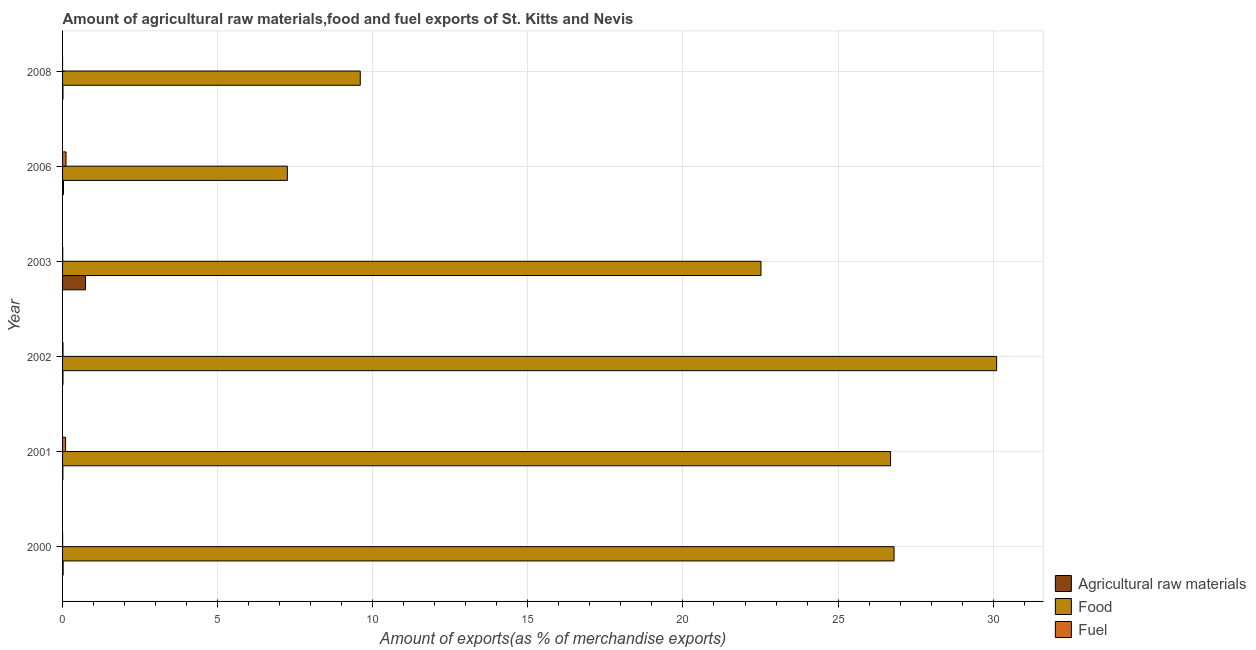How many different coloured bars are there?
Your answer should be very brief. 3. How many groups of bars are there?
Keep it short and to the point. 6. Are the number of bars per tick equal to the number of legend labels?
Keep it short and to the point. Yes. Are the number of bars on each tick of the Y-axis equal?
Ensure brevity in your answer.  Yes. What is the label of the 1st group of bars from the top?
Provide a succinct answer. 2008. In how many cases, is the number of bars for a given year not equal to the number of legend labels?
Provide a short and direct response. 0. What is the percentage of raw materials exports in 2003?
Your answer should be very brief. 0.74. Across all years, what is the maximum percentage of food exports?
Make the answer very short. 30.11. Across all years, what is the minimum percentage of food exports?
Your answer should be compact. 7.25. In which year was the percentage of food exports minimum?
Offer a terse response. 2006. What is the total percentage of raw materials exports in the graph?
Your answer should be compact. 0.82. What is the difference between the percentage of fuel exports in 2002 and that in 2006?
Offer a terse response. -0.1. What is the difference between the percentage of fuel exports in 2006 and the percentage of raw materials exports in 2008?
Provide a succinct answer. 0.1. What is the average percentage of food exports per year?
Make the answer very short. 20.49. In the year 2006, what is the difference between the percentage of food exports and percentage of fuel exports?
Your answer should be compact. 7.14. What is the ratio of the percentage of raw materials exports in 2003 to that in 2006?
Make the answer very short. 24.98. Is the difference between the percentage of fuel exports in 2002 and 2008 greater than the difference between the percentage of food exports in 2002 and 2008?
Your response must be concise. No. What is the difference between the highest and the second highest percentage of raw materials exports?
Ensure brevity in your answer.  0.71. What is the difference between the highest and the lowest percentage of raw materials exports?
Give a very brief answer. 0.73. In how many years, is the percentage of raw materials exports greater than the average percentage of raw materials exports taken over all years?
Ensure brevity in your answer.  1. Is the sum of the percentage of fuel exports in 2000 and 2008 greater than the maximum percentage of food exports across all years?
Your answer should be compact. No. What does the 3rd bar from the top in 2003 represents?
Keep it short and to the point. Agricultural raw materials. What does the 1st bar from the bottom in 2000 represents?
Your answer should be very brief. Agricultural raw materials. Is it the case that in every year, the sum of the percentage of raw materials exports and percentage of food exports is greater than the percentage of fuel exports?
Provide a short and direct response. Yes. How many years are there in the graph?
Keep it short and to the point. 6. Are the values on the major ticks of X-axis written in scientific E-notation?
Ensure brevity in your answer.  No. How are the legend labels stacked?
Offer a very short reply. Vertical. What is the title of the graph?
Keep it short and to the point. Amount of agricultural raw materials,food and fuel exports of St. Kitts and Nevis. Does "Ages 50+" appear as one of the legend labels in the graph?
Your answer should be compact. No. What is the label or title of the X-axis?
Your response must be concise. Amount of exports(as % of merchandise exports). What is the Amount of exports(as % of merchandise exports) in Agricultural raw materials in 2000?
Make the answer very short. 0.02. What is the Amount of exports(as % of merchandise exports) of Food in 2000?
Provide a succinct answer. 26.8. What is the Amount of exports(as % of merchandise exports) in Fuel in 2000?
Your answer should be very brief. 0. What is the Amount of exports(as % of merchandise exports) in Agricultural raw materials in 2001?
Your answer should be compact. 0.01. What is the Amount of exports(as % of merchandise exports) of Food in 2001?
Your response must be concise. 26.69. What is the Amount of exports(as % of merchandise exports) of Fuel in 2001?
Offer a terse response. 0.1. What is the Amount of exports(as % of merchandise exports) of Agricultural raw materials in 2002?
Your response must be concise. 0.01. What is the Amount of exports(as % of merchandise exports) of Food in 2002?
Your answer should be compact. 30.11. What is the Amount of exports(as % of merchandise exports) in Fuel in 2002?
Provide a succinct answer. 0.01. What is the Amount of exports(as % of merchandise exports) of Agricultural raw materials in 2003?
Provide a short and direct response. 0.74. What is the Amount of exports(as % of merchandise exports) of Food in 2003?
Your answer should be compact. 22.51. What is the Amount of exports(as % of merchandise exports) in Fuel in 2003?
Keep it short and to the point. 0.01. What is the Amount of exports(as % of merchandise exports) of Agricultural raw materials in 2006?
Provide a succinct answer. 0.03. What is the Amount of exports(as % of merchandise exports) of Food in 2006?
Keep it short and to the point. 7.25. What is the Amount of exports(as % of merchandise exports) in Fuel in 2006?
Your answer should be very brief. 0.11. What is the Amount of exports(as % of merchandise exports) in Agricultural raw materials in 2008?
Offer a very short reply. 0.01. What is the Amount of exports(as % of merchandise exports) of Food in 2008?
Your answer should be very brief. 9.6. What is the Amount of exports(as % of merchandise exports) in Fuel in 2008?
Your answer should be very brief. 6.97416001647576e-6. Across all years, what is the maximum Amount of exports(as % of merchandise exports) of Agricultural raw materials?
Make the answer very short. 0.74. Across all years, what is the maximum Amount of exports(as % of merchandise exports) in Food?
Provide a succinct answer. 30.11. Across all years, what is the maximum Amount of exports(as % of merchandise exports) in Fuel?
Give a very brief answer. 0.11. Across all years, what is the minimum Amount of exports(as % of merchandise exports) of Agricultural raw materials?
Make the answer very short. 0.01. Across all years, what is the minimum Amount of exports(as % of merchandise exports) in Food?
Your answer should be compact. 7.25. Across all years, what is the minimum Amount of exports(as % of merchandise exports) in Fuel?
Offer a very short reply. 6.97416001647576e-6. What is the total Amount of exports(as % of merchandise exports) in Agricultural raw materials in the graph?
Your answer should be compact. 0.82. What is the total Amount of exports(as % of merchandise exports) in Food in the graph?
Give a very brief answer. 122.97. What is the total Amount of exports(as % of merchandise exports) in Fuel in the graph?
Make the answer very short. 0.23. What is the difference between the Amount of exports(as % of merchandise exports) in Agricultural raw materials in 2000 and that in 2001?
Ensure brevity in your answer.  0.01. What is the difference between the Amount of exports(as % of merchandise exports) of Food in 2000 and that in 2001?
Provide a succinct answer. 0.11. What is the difference between the Amount of exports(as % of merchandise exports) of Fuel in 2000 and that in 2001?
Your answer should be compact. -0.1. What is the difference between the Amount of exports(as % of merchandise exports) of Agricultural raw materials in 2000 and that in 2002?
Ensure brevity in your answer.  0. What is the difference between the Amount of exports(as % of merchandise exports) of Food in 2000 and that in 2002?
Make the answer very short. -3.31. What is the difference between the Amount of exports(as % of merchandise exports) in Fuel in 2000 and that in 2002?
Offer a very short reply. -0.01. What is the difference between the Amount of exports(as % of merchandise exports) of Agricultural raw materials in 2000 and that in 2003?
Keep it short and to the point. -0.72. What is the difference between the Amount of exports(as % of merchandise exports) in Food in 2000 and that in 2003?
Your response must be concise. 4.29. What is the difference between the Amount of exports(as % of merchandise exports) of Fuel in 2000 and that in 2003?
Offer a very short reply. -0. What is the difference between the Amount of exports(as % of merchandise exports) of Agricultural raw materials in 2000 and that in 2006?
Make the answer very short. -0.01. What is the difference between the Amount of exports(as % of merchandise exports) of Food in 2000 and that in 2006?
Your answer should be compact. 19.56. What is the difference between the Amount of exports(as % of merchandise exports) in Fuel in 2000 and that in 2006?
Your answer should be very brief. -0.11. What is the difference between the Amount of exports(as % of merchandise exports) of Agricultural raw materials in 2000 and that in 2008?
Give a very brief answer. 0. What is the difference between the Amount of exports(as % of merchandise exports) of Food in 2000 and that in 2008?
Offer a terse response. 17.21. What is the difference between the Amount of exports(as % of merchandise exports) of Fuel in 2000 and that in 2008?
Your answer should be compact. 0. What is the difference between the Amount of exports(as % of merchandise exports) of Agricultural raw materials in 2001 and that in 2002?
Make the answer very short. -0. What is the difference between the Amount of exports(as % of merchandise exports) of Food in 2001 and that in 2002?
Offer a very short reply. -3.42. What is the difference between the Amount of exports(as % of merchandise exports) of Fuel in 2001 and that in 2002?
Keep it short and to the point. 0.08. What is the difference between the Amount of exports(as % of merchandise exports) in Agricultural raw materials in 2001 and that in 2003?
Offer a very short reply. -0.73. What is the difference between the Amount of exports(as % of merchandise exports) of Food in 2001 and that in 2003?
Offer a terse response. 4.18. What is the difference between the Amount of exports(as % of merchandise exports) in Fuel in 2001 and that in 2003?
Keep it short and to the point. 0.09. What is the difference between the Amount of exports(as % of merchandise exports) in Agricultural raw materials in 2001 and that in 2006?
Make the answer very short. -0.02. What is the difference between the Amount of exports(as % of merchandise exports) in Food in 2001 and that in 2006?
Your response must be concise. 19.45. What is the difference between the Amount of exports(as % of merchandise exports) in Fuel in 2001 and that in 2006?
Your answer should be compact. -0.01. What is the difference between the Amount of exports(as % of merchandise exports) in Agricultural raw materials in 2001 and that in 2008?
Offer a very short reply. -0. What is the difference between the Amount of exports(as % of merchandise exports) of Food in 2001 and that in 2008?
Provide a succinct answer. 17.1. What is the difference between the Amount of exports(as % of merchandise exports) of Fuel in 2001 and that in 2008?
Give a very brief answer. 0.1. What is the difference between the Amount of exports(as % of merchandise exports) of Agricultural raw materials in 2002 and that in 2003?
Your answer should be very brief. -0.73. What is the difference between the Amount of exports(as % of merchandise exports) in Food in 2002 and that in 2003?
Your response must be concise. 7.6. What is the difference between the Amount of exports(as % of merchandise exports) of Fuel in 2002 and that in 2003?
Offer a terse response. 0.01. What is the difference between the Amount of exports(as % of merchandise exports) in Agricultural raw materials in 2002 and that in 2006?
Keep it short and to the point. -0.02. What is the difference between the Amount of exports(as % of merchandise exports) in Food in 2002 and that in 2006?
Provide a short and direct response. 22.87. What is the difference between the Amount of exports(as % of merchandise exports) in Fuel in 2002 and that in 2006?
Offer a very short reply. -0.1. What is the difference between the Amount of exports(as % of merchandise exports) of Agricultural raw materials in 2002 and that in 2008?
Your answer should be compact. -0. What is the difference between the Amount of exports(as % of merchandise exports) in Food in 2002 and that in 2008?
Keep it short and to the point. 20.52. What is the difference between the Amount of exports(as % of merchandise exports) in Fuel in 2002 and that in 2008?
Make the answer very short. 0.01. What is the difference between the Amount of exports(as % of merchandise exports) in Agricultural raw materials in 2003 and that in 2006?
Your answer should be compact. 0.71. What is the difference between the Amount of exports(as % of merchandise exports) of Food in 2003 and that in 2006?
Your answer should be very brief. 15.27. What is the difference between the Amount of exports(as % of merchandise exports) of Fuel in 2003 and that in 2006?
Your answer should be compact. -0.1. What is the difference between the Amount of exports(as % of merchandise exports) in Agricultural raw materials in 2003 and that in 2008?
Keep it short and to the point. 0.73. What is the difference between the Amount of exports(as % of merchandise exports) of Food in 2003 and that in 2008?
Your answer should be very brief. 12.92. What is the difference between the Amount of exports(as % of merchandise exports) of Fuel in 2003 and that in 2008?
Offer a terse response. 0.01. What is the difference between the Amount of exports(as % of merchandise exports) in Agricultural raw materials in 2006 and that in 2008?
Your answer should be very brief. 0.02. What is the difference between the Amount of exports(as % of merchandise exports) in Food in 2006 and that in 2008?
Provide a succinct answer. -2.35. What is the difference between the Amount of exports(as % of merchandise exports) of Fuel in 2006 and that in 2008?
Give a very brief answer. 0.11. What is the difference between the Amount of exports(as % of merchandise exports) of Agricultural raw materials in 2000 and the Amount of exports(as % of merchandise exports) of Food in 2001?
Offer a terse response. -26.67. What is the difference between the Amount of exports(as % of merchandise exports) in Agricultural raw materials in 2000 and the Amount of exports(as % of merchandise exports) in Fuel in 2001?
Offer a very short reply. -0.08. What is the difference between the Amount of exports(as % of merchandise exports) in Food in 2000 and the Amount of exports(as % of merchandise exports) in Fuel in 2001?
Offer a very short reply. 26.71. What is the difference between the Amount of exports(as % of merchandise exports) of Agricultural raw materials in 2000 and the Amount of exports(as % of merchandise exports) of Food in 2002?
Offer a very short reply. -30.09. What is the difference between the Amount of exports(as % of merchandise exports) in Agricultural raw materials in 2000 and the Amount of exports(as % of merchandise exports) in Fuel in 2002?
Offer a terse response. 0. What is the difference between the Amount of exports(as % of merchandise exports) of Food in 2000 and the Amount of exports(as % of merchandise exports) of Fuel in 2002?
Your answer should be compact. 26.79. What is the difference between the Amount of exports(as % of merchandise exports) of Agricultural raw materials in 2000 and the Amount of exports(as % of merchandise exports) of Food in 2003?
Ensure brevity in your answer.  -22.5. What is the difference between the Amount of exports(as % of merchandise exports) of Agricultural raw materials in 2000 and the Amount of exports(as % of merchandise exports) of Fuel in 2003?
Your answer should be very brief. 0.01. What is the difference between the Amount of exports(as % of merchandise exports) in Food in 2000 and the Amount of exports(as % of merchandise exports) in Fuel in 2003?
Your answer should be compact. 26.8. What is the difference between the Amount of exports(as % of merchandise exports) of Agricultural raw materials in 2000 and the Amount of exports(as % of merchandise exports) of Food in 2006?
Your answer should be compact. -7.23. What is the difference between the Amount of exports(as % of merchandise exports) in Agricultural raw materials in 2000 and the Amount of exports(as % of merchandise exports) in Fuel in 2006?
Your response must be concise. -0.09. What is the difference between the Amount of exports(as % of merchandise exports) in Food in 2000 and the Amount of exports(as % of merchandise exports) in Fuel in 2006?
Your answer should be compact. 26.69. What is the difference between the Amount of exports(as % of merchandise exports) of Agricultural raw materials in 2000 and the Amount of exports(as % of merchandise exports) of Food in 2008?
Your answer should be very brief. -9.58. What is the difference between the Amount of exports(as % of merchandise exports) of Agricultural raw materials in 2000 and the Amount of exports(as % of merchandise exports) of Fuel in 2008?
Your response must be concise. 0.02. What is the difference between the Amount of exports(as % of merchandise exports) of Food in 2000 and the Amount of exports(as % of merchandise exports) of Fuel in 2008?
Your answer should be compact. 26.8. What is the difference between the Amount of exports(as % of merchandise exports) of Agricultural raw materials in 2001 and the Amount of exports(as % of merchandise exports) of Food in 2002?
Provide a short and direct response. -30.1. What is the difference between the Amount of exports(as % of merchandise exports) of Agricultural raw materials in 2001 and the Amount of exports(as % of merchandise exports) of Fuel in 2002?
Your answer should be compact. -0. What is the difference between the Amount of exports(as % of merchandise exports) of Food in 2001 and the Amount of exports(as % of merchandise exports) of Fuel in 2002?
Offer a terse response. 26.68. What is the difference between the Amount of exports(as % of merchandise exports) of Agricultural raw materials in 2001 and the Amount of exports(as % of merchandise exports) of Food in 2003?
Provide a short and direct response. -22.51. What is the difference between the Amount of exports(as % of merchandise exports) in Agricultural raw materials in 2001 and the Amount of exports(as % of merchandise exports) in Fuel in 2003?
Make the answer very short. 0. What is the difference between the Amount of exports(as % of merchandise exports) of Food in 2001 and the Amount of exports(as % of merchandise exports) of Fuel in 2003?
Your answer should be compact. 26.69. What is the difference between the Amount of exports(as % of merchandise exports) of Agricultural raw materials in 2001 and the Amount of exports(as % of merchandise exports) of Food in 2006?
Ensure brevity in your answer.  -7.24. What is the difference between the Amount of exports(as % of merchandise exports) of Agricultural raw materials in 2001 and the Amount of exports(as % of merchandise exports) of Fuel in 2006?
Your response must be concise. -0.1. What is the difference between the Amount of exports(as % of merchandise exports) in Food in 2001 and the Amount of exports(as % of merchandise exports) in Fuel in 2006?
Your answer should be compact. 26.58. What is the difference between the Amount of exports(as % of merchandise exports) in Agricultural raw materials in 2001 and the Amount of exports(as % of merchandise exports) in Food in 2008?
Your response must be concise. -9.59. What is the difference between the Amount of exports(as % of merchandise exports) in Agricultural raw materials in 2001 and the Amount of exports(as % of merchandise exports) in Fuel in 2008?
Your answer should be very brief. 0.01. What is the difference between the Amount of exports(as % of merchandise exports) in Food in 2001 and the Amount of exports(as % of merchandise exports) in Fuel in 2008?
Make the answer very short. 26.69. What is the difference between the Amount of exports(as % of merchandise exports) in Agricultural raw materials in 2002 and the Amount of exports(as % of merchandise exports) in Food in 2003?
Offer a very short reply. -22.5. What is the difference between the Amount of exports(as % of merchandise exports) in Agricultural raw materials in 2002 and the Amount of exports(as % of merchandise exports) in Fuel in 2003?
Provide a succinct answer. 0.01. What is the difference between the Amount of exports(as % of merchandise exports) of Food in 2002 and the Amount of exports(as % of merchandise exports) of Fuel in 2003?
Your response must be concise. 30.11. What is the difference between the Amount of exports(as % of merchandise exports) in Agricultural raw materials in 2002 and the Amount of exports(as % of merchandise exports) in Food in 2006?
Offer a very short reply. -7.23. What is the difference between the Amount of exports(as % of merchandise exports) in Agricultural raw materials in 2002 and the Amount of exports(as % of merchandise exports) in Fuel in 2006?
Give a very brief answer. -0.1. What is the difference between the Amount of exports(as % of merchandise exports) in Food in 2002 and the Amount of exports(as % of merchandise exports) in Fuel in 2006?
Your answer should be very brief. 30. What is the difference between the Amount of exports(as % of merchandise exports) of Agricultural raw materials in 2002 and the Amount of exports(as % of merchandise exports) of Food in 2008?
Your response must be concise. -9.58. What is the difference between the Amount of exports(as % of merchandise exports) in Agricultural raw materials in 2002 and the Amount of exports(as % of merchandise exports) in Fuel in 2008?
Provide a succinct answer. 0.01. What is the difference between the Amount of exports(as % of merchandise exports) of Food in 2002 and the Amount of exports(as % of merchandise exports) of Fuel in 2008?
Give a very brief answer. 30.11. What is the difference between the Amount of exports(as % of merchandise exports) of Agricultural raw materials in 2003 and the Amount of exports(as % of merchandise exports) of Food in 2006?
Offer a very short reply. -6.51. What is the difference between the Amount of exports(as % of merchandise exports) of Agricultural raw materials in 2003 and the Amount of exports(as % of merchandise exports) of Fuel in 2006?
Ensure brevity in your answer.  0.63. What is the difference between the Amount of exports(as % of merchandise exports) of Food in 2003 and the Amount of exports(as % of merchandise exports) of Fuel in 2006?
Make the answer very short. 22.4. What is the difference between the Amount of exports(as % of merchandise exports) of Agricultural raw materials in 2003 and the Amount of exports(as % of merchandise exports) of Food in 2008?
Your answer should be compact. -8.86. What is the difference between the Amount of exports(as % of merchandise exports) in Agricultural raw materials in 2003 and the Amount of exports(as % of merchandise exports) in Fuel in 2008?
Your answer should be very brief. 0.74. What is the difference between the Amount of exports(as % of merchandise exports) of Food in 2003 and the Amount of exports(as % of merchandise exports) of Fuel in 2008?
Ensure brevity in your answer.  22.51. What is the difference between the Amount of exports(as % of merchandise exports) in Agricultural raw materials in 2006 and the Amount of exports(as % of merchandise exports) in Food in 2008?
Provide a short and direct response. -9.57. What is the difference between the Amount of exports(as % of merchandise exports) of Agricultural raw materials in 2006 and the Amount of exports(as % of merchandise exports) of Fuel in 2008?
Your answer should be very brief. 0.03. What is the difference between the Amount of exports(as % of merchandise exports) of Food in 2006 and the Amount of exports(as % of merchandise exports) of Fuel in 2008?
Your answer should be compact. 7.25. What is the average Amount of exports(as % of merchandise exports) of Agricultural raw materials per year?
Ensure brevity in your answer.  0.14. What is the average Amount of exports(as % of merchandise exports) in Food per year?
Keep it short and to the point. 20.49. What is the average Amount of exports(as % of merchandise exports) in Fuel per year?
Your answer should be very brief. 0.04. In the year 2000, what is the difference between the Amount of exports(as % of merchandise exports) of Agricultural raw materials and Amount of exports(as % of merchandise exports) of Food?
Your answer should be very brief. -26.79. In the year 2000, what is the difference between the Amount of exports(as % of merchandise exports) in Agricultural raw materials and Amount of exports(as % of merchandise exports) in Fuel?
Offer a very short reply. 0.02. In the year 2000, what is the difference between the Amount of exports(as % of merchandise exports) in Food and Amount of exports(as % of merchandise exports) in Fuel?
Offer a terse response. 26.8. In the year 2001, what is the difference between the Amount of exports(as % of merchandise exports) of Agricultural raw materials and Amount of exports(as % of merchandise exports) of Food?
Make the answer very short. -26.68. In the year 2001, what is the difference between the Amount of exports(as % of merchandise exports) in Agricultural raw materials and Amount of exports(as % of merchandise exports) in Fuel?
Provide a short and direct response. -0.09. In the year 2001, what is the difference between the Amount of exports(as % of merchandise exports) in Food and Amount of exports(as % of merchandise exports) in Fuel?
Offer a very short reply. 26.59. In the year 2002, what is the difference between the Amount of exports(as % of merchandise exports) in Agricultural raw materials and Amount of exports(as % of merchandise exports) in Food?
Give a very brief answer. -30.1. In the year 2002, what is the difference between the Amount of exports(as % of merchandise exports) of Agricultural raw materials and Amount of exports(as % of merchandise exports) of Fuel?
Offer a very short reply. -0. In the year 2002, what is the difference between the Amount of exports(as % of merchandise exports) of Food and Amount of exports(as % of merchandise exports) of Fuel?
Offer a terse response. 30.1. In the year 2003, what is the difference between the Amount of exports(as % of merchandise exports) of Agricultural raw materials and Amount of exports(as % of merchandise exports) of Food?
Offer a terse response. -21.77. In the year 2003, what is the difference between the Amount of exports(as % of merchandise exports) of Agricultural raw materials and Amount of exports(as % of merchandise exports) of Fuel?
Your answer should be very brief. 0.73. In the year 2003, what is the difference between the Amount of exports(as % of merchandise exports) in Food and Amount of exports(as % of merchandise exports) in Fuel?
Offer a very short reply. 22.51. In the year 2006, what is the difference between the Amount of exports(as % of merchandise exports) in Agricultural raw materials and Amount of exports(as % of merchandise exports) in Food?
Keep it short and to the point. -7.22. In the year 2006, what is the difference between the Amount of exports(as % of merchandise exports) in Agricultural raw materials and Amount of exports(as % of merchandise exports) in Fuel?
Ensure brevity in your answer.  -0.08. In the year 2006, what is the difference between the Amount of exports(as % of merchandise exports) of Food and Amount of exports(as % of merchandise exports) of Fuel?
Offer a very short reply. 7.14. In the year 2008, what is the difference between the Amount of exports(as % of merchandise exports) of Agricultural raw materials and Amount of exports(as % of merchandise exports) of Food?
Your response must be concise. -9.58. In the year 2008, what is the difference between the Amount of exports(as % of merchandise exports) in Agricultural raw materials and Amount of exports(as % of merchandise exports) in Fuel?
Provide a short and direct response. 0.01. In the year 2008, what is the difference between the Amount of exports(as % of merchandise exports) in Food and Amount of exports(as % of merchandise exports) in Fuel?
Provide a short and direct response. 9.6. What is the ratio of the Amount of exports(as % of merchandise exports) of Agricultural raw materials in 2000 to that in 2001?
Provide a short and direct response. 1.95. What is the ratio of the Amount of exports(as % of merchandise exports) of Fuel in 2000 to that in 2001?
Your response must be concise. 0.02. What is the ratio of the Amount of exports(as % of merchandise exports) of Agricultural raw materials in 2000 to that in 2002?
Your response must be concise. 1.36. What is the ratio of the Amount of exports(as % of merchandise exports) in Food in 2000 to that in 2002?
Offer a terse response. 0.89. What is the ratio of the Amount of exports(as % of merchandise exports) of Fuel in 2000 to that in 2002?
Offer a very short reply. 0.15. What is the ratio of the Amount of exports(as % of merchandise exports) in Agricultural raw materials in 2000 to that in 2003?
Give a very brief answer. 0.02. What is the ratio of the Amount of exports(as % of merchandise exports) of Food in 2000 to that in 2003?
Ensure brevity in your answer.  1.19. What is the ratio of the Amount of exports(as % of merchandise exports) in Fuel in 2000 to that in 2003?
Your response must be concise. 0.35. What is the ratio of the Amount of exports(as % of merchandise exports) in Agricultural raw materials in 2000 to that in 2006?
Keep it short and to the point. 0.62. What is the ratio of the Amount of exports(as % of merchandise exports) in Food in 2000 to that in 2006?
Keep it short and to the point. 3.7. What is the ratio of the Amount of exports(as % of merchandise exports) in Fuel in 2000 to that in 2006?
Keep it short and to the point. 0.02. What is the ratio of the Amount of exports(as % of merchandise exports) in Agricultural raw materials in 2000 to that in 2008?
Keep it short and to the point. 1.34. What is the ratio of the Amount of exports(as % of merchandise exports) in Food in 2000 to that in 2008?
Your answer should be very brief. 2.79. What is the ratio of the Amount of exports(as % of merchandise exports) of Fuel in 2000 to that in 2008?
Ensure brevity in your answer.  300.71. What is the ratio of the Amount of exports(as % of merchandise exports) of Agricultural raw materials in 2001 to that in 2002?
Your answer should be compact. 0.7. What is the ratio of the Amount of exports(as % of merchandise exports) of Food in 2001 to that in 2002?
Your answer should be very brief. 0.89. What is the ratio of the Amount of exports(as % of merchandise exports) in Fuel in 2001 to that in 2002?
Give a very brief answer. 7.12. What is the ratio of the Amount of exports(as % of merchandise exports) of Agricultural raw materials in 2001 to that in 2003?
Keep it short and to the point. 0.01. What is the ratio of the Amount of exports(as % of merchandise exports) of Food in 2001 to that in 2003?
Keep it short and to the point. 1.19. What is the ratio of the Amount of exports(as % of merchandise exports) of Fuel in 2001 to that in 2003?
Your response must be concise. 16.37. What is the ratio of the Amount of exports(as % of merchandise exports) in Agricultural raw materials in 2001 to that in 2006?
Give a very brief answer. 0.32. What is the ratio of the Amount of exports(as % of merchandise exports) in Food in 2001 to that in 2006?
Offer a very short reply. 3.68. What is the ratio of the Amount of exports(as % of merchandise exports) of Fuel in 2001 to that in 2006?
Provide a succinct answer. 0.88. What is the ratio of the Amount of exports(as % of merchandise exports) of Agricultural raw materials in 2001 to that in 2008?
Provide a succinct answer. 0.69. What is the ratio of the Amount of exports(as % of merchandise exports) in Food in 2001 to that in 2008?
Provide a succinct answer. 2.78. What is the ratio of the Amount of exports(as % of merchandise exports) in Fuel in 2001 to that in 2008?
Give a very brief answer. 1.41e+04. What is the ratio of the Amount of exports(as % of merchandise exports) in Agricultural raw materials in 2002 to that in 2003?
Give a very brief answer. 0.02. What is the ratio of the Amount of exports(as % of merchandise exports) of Food in 2002 to that in 2003?
Offer a terse response. 1.34. What is the ratio of the Amount of exports(as % of merchandise exports) in Fuel in 2002 to that in 2003?
Your response must be concise. 2.3. What is the ratio of the Amount of exports(as % of merchandise exports) of Agricultural raw materials in 2002 to that in 2006?
Offer a very short reply. 0.45. What is the ratio of the Amount of exports(as % of merchandise exports) of Food in 2002 to that in 2006?
Make the answer very short. 4.16. What is the ratio of the Amount of exports(as % of merchandise exports) in Fuel in 2002 to that in 2006?
Make the answer very short. 0.12. What is the ratio of the Amount of exports(as % of merchandise exports) of Food in 2002 to that in 2008?
Make the answer very short. 3.14. What is the ratio of the Amount of exports(as % of merchandise exports) of Fuel in 2002 to that in 2008?
Your answer should be very brief. 1974.92. What is the ratio of the Amount of exports(as % of merchandise exports) of Agricultural raw materials in 2003 to that in 2006?
Your answer should be very brief. 24.98. What is the ratio of the Amount of exports(as % of merchandise exports) of Food in 2003 to that in 2006?
Offer a very short reply. 3.11. What is the ratio of the Amount of exports(as % of merchandise exports) of Fuel in 2003 to that in 2006?
Offer a very short reply. 0.05. What is the ratio of the Amount of exports(as % of merchandise exports) of Agricultural raw materials in 2003 to that in 2008?
Ensure brevity in your answer.  54.47. What is the ratio of the Amount of exports(as % of merchandise exports) in Food in 2003 to that in 2008?
Give a very brief answer. 2.35. What is the ratio of the Amount of exports(as % of merchandise exports) of Fuel in 2003 to that in 2008?
Provide a short and direct response. 859.39. What is the ratio of the Amount of exports(as % of merchandise exports) of Agricultural raw materials in 2006 to that in 2008?
Your response must be concise. 2.18. What is the ratio of the Amount of exports(as % of merchandise exports) in Food in 2006 to that in 2008?
Provide a short and direct response. 0.76. What is the ratio of the Amount of exports(as % of merchandise exports) in Fuel in 2006 to that in 2008?
Your answer should be very brief. 1.59e+04. What is the difference between the highest and the second highest Amount of exports(as % of merchandise exports) in Agricultural raw materials?
Keep it short and to the point. 0.71. What is the difference between the highest and the second highest Amount of exports(as % of merchandise exports) in Food?
Offer a terse response. 3.31. What is the difference between the highest and the second highest Amount of exports(as % of merchandise exports) of Fuel?
Provide a succinct answer. 0.01. What is the difference between the highest and the lowest Amount of exports(as % of merchandise exports) of Agricultural raw materials?
Make the answer very short. 0.73. What is the difference between the highest and the lowest Amount of exports(as % of merchandise exports) in Food?
Your answer should be very brief. 22.87. What is the difference between the highest and the lowest Amount of exports(as % of merchandise exports) in Fuel?
Provide a succinct answer. 0.11. 